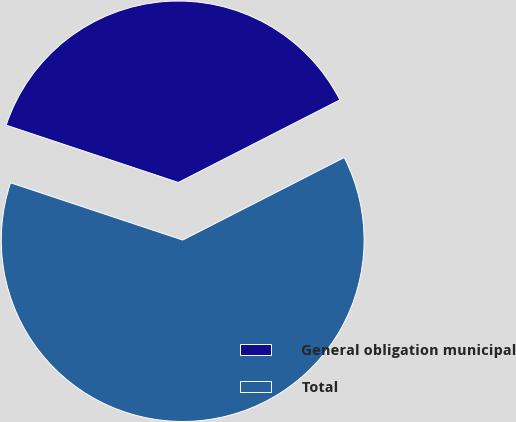Convert chart. <chart><loc_0><loc_0><loc_500><loc_500><pie_chart><fcel>General obligation municipal<fcel>Total<nl><fcel>37.37%<fcel>62.63%<nl></chart> 